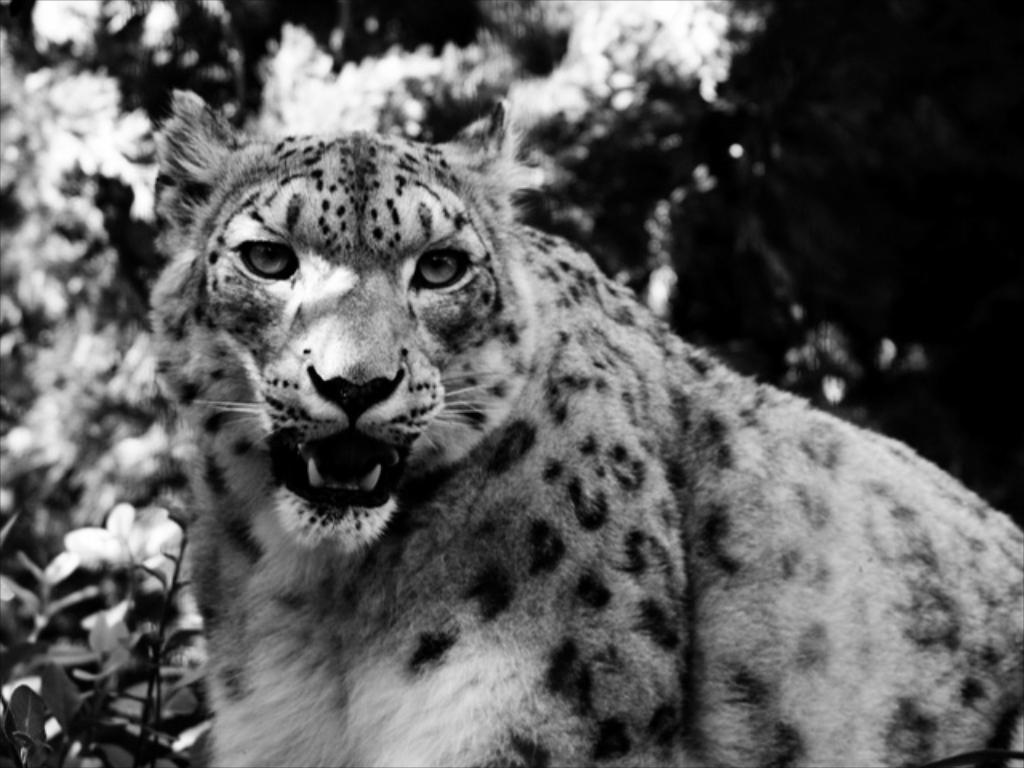How would you summarize this image in a sentence or two? In this image we can see an animal, flowers, leaves. 